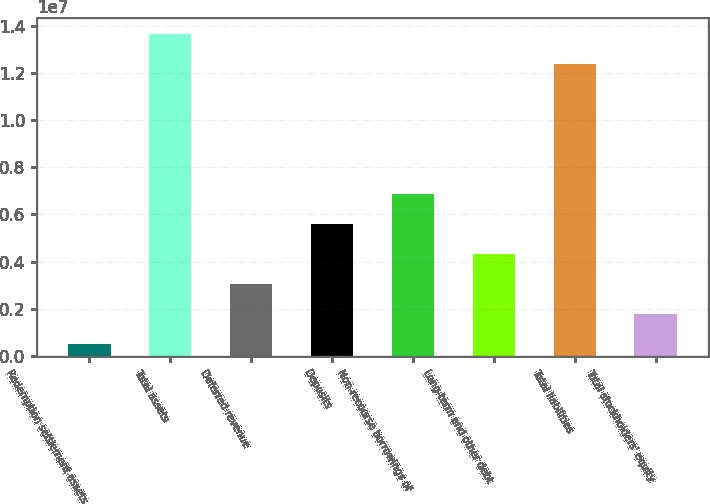Convert chart. <chart><loc_0><loc_0><loc_500><loc_500><bar_chart><fcel>Redemption settlement assets<fcel>Total assets<fcel>Deferred revenue<fcel>Deposits<fcel>Non-recourse borrowings of<fcel>Long-term and other debt<fcel>Total liabilities<fcel>Total stockholders' equity<nl><fcel>510349<fcel>1.36619e+07<fcel>3.05713e+06<fcel>5.60391e+06<fcel>6.8773e+06<fcel>4.33052e+06<fcel>1.23885e+07<fcel>1.78374e+06<nl></chart> 